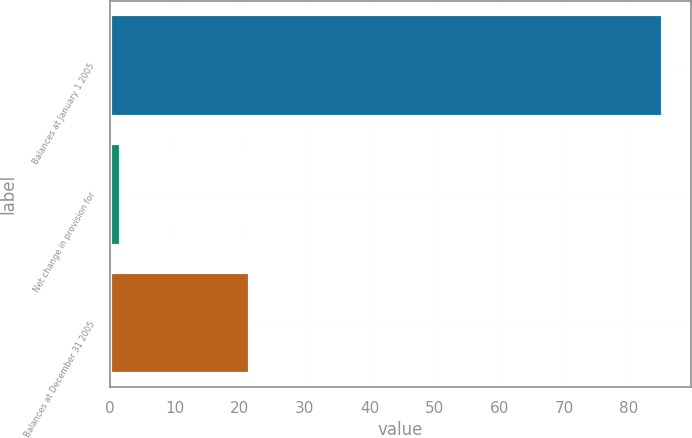Convert chart. <chart><loc_0><loc_0><loc_500><loc_500><bar_chart><fcel>Balances at January 1 2005<fcel>Net change in provision for<fcel>Balances at December 31 2005<nl><fcel>85.3<fcel>1.6<fcel>21.6<nl></chart> 